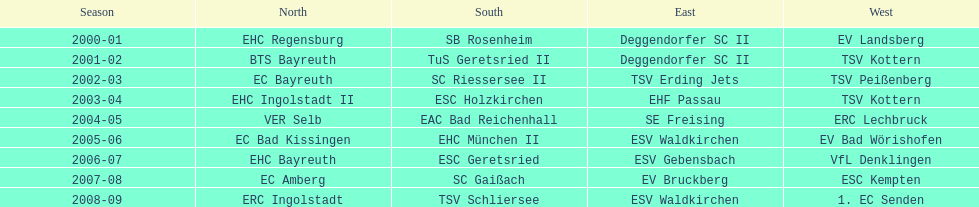Who secured the title in the north preceding ec bayreuth's triumph in 2002-03? BTS Bayreuth. Write the full table. {'header': ['Season', 'North', 'South', 'East', 'West'], 'rows': [['2000-01', 'EHC Regensburg', 'SB Rosenheim', 'Deggendorfer SC II', 'EV Landsberg'], ['2001-02', 'BTS Bayreuth', 'TuS Geretsried II', 'Deggendorfer SC II', 'TSV Kottern'], ['2002-03', 'EC Bayreuth', 'SC Riessersee II', 'TSV Erding Jets', 'TSV Peißenberg'], ['2003-04', 'EHC Ingolstadt II', 'ESC Holzkirchen', 'EHF Passau', 'TSV Kottern'], ['2004-05', 'VER Selb', 'EAC Bad Reichenhall', 'SE Freising', 'ERC Lechbruck'], ['2005-06', 'EC Bad Kissingen', 'EHC München II', 'ESV Waldkirchen', 'EV Bad Wörishofen'], ['2006-07', 'EHC Bayreuth', 'ESC Geretsried', 'ESV Gebensbach', 'VfL Denklingen'], ['2007-08', 'EC Amberg', 'SC Gaißach', 'EV Bruckberg', 'ESC Kempten'], ['2008-09', 'ERC Ingolstadt', 'TSV Schliersee', 'ESV Waldkirchen', '1. EC Senden']]} 